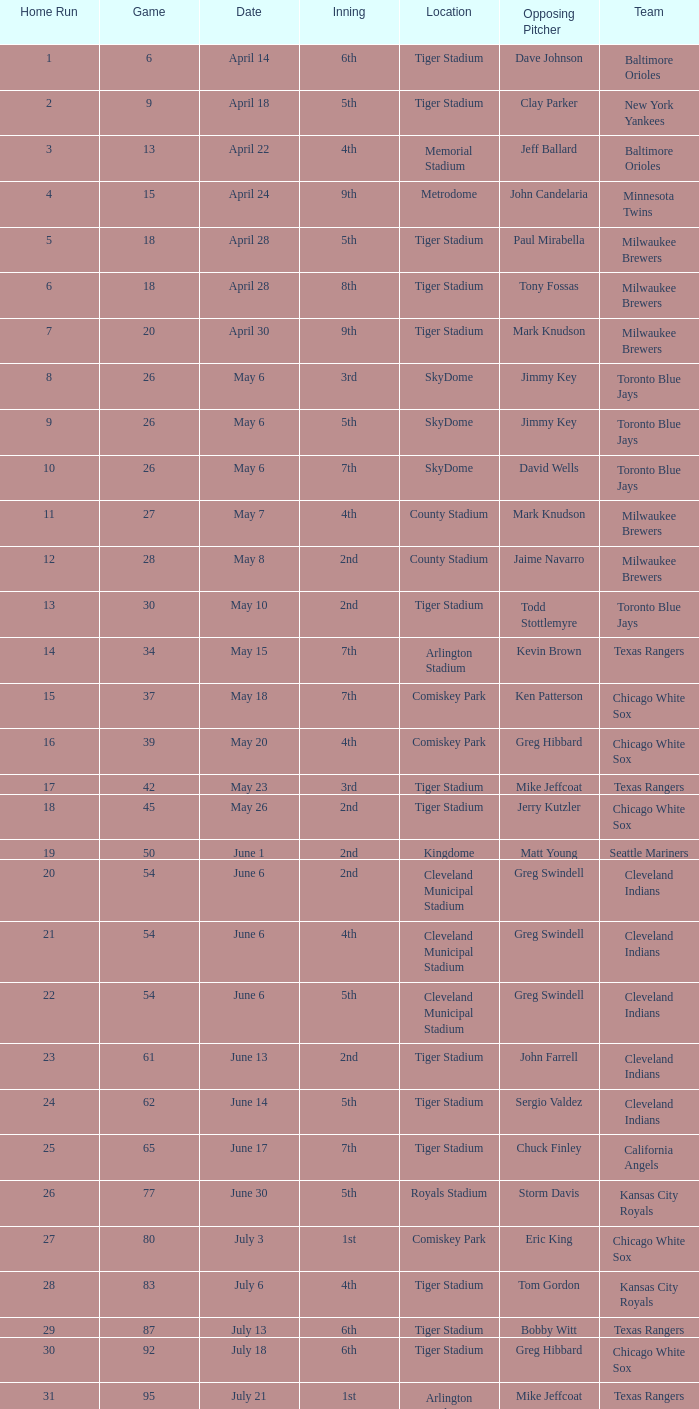When Efrain Valdez was pitching, what was the highest home run? 39.0. 